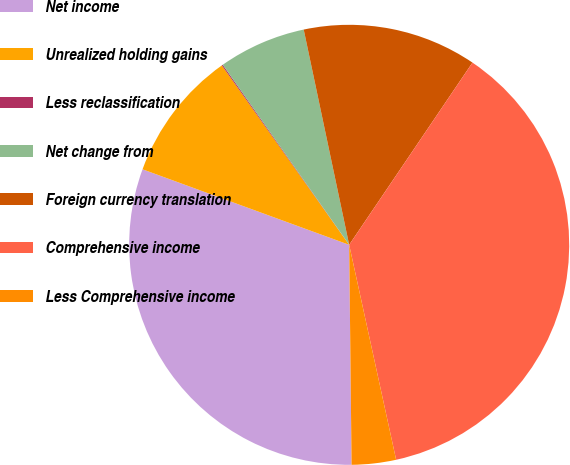<chart> <loc_0><loc_0><loc_500><loc_500><pie_chart><fcel>Net income<fcel>Unrealized holding gains<fcel>Less reclassification<fcel>Net change from<fcel>Foreign currency translation<fcel>Comprehensive income<fcel>Less Comprehensive income<nl><fcel>30.75%<fcel>9.6%<fcel>0.08%<fcel>6.43%<fcel>12.78%<fcel>37.11%<fcel>3.25%<nl></chart> 